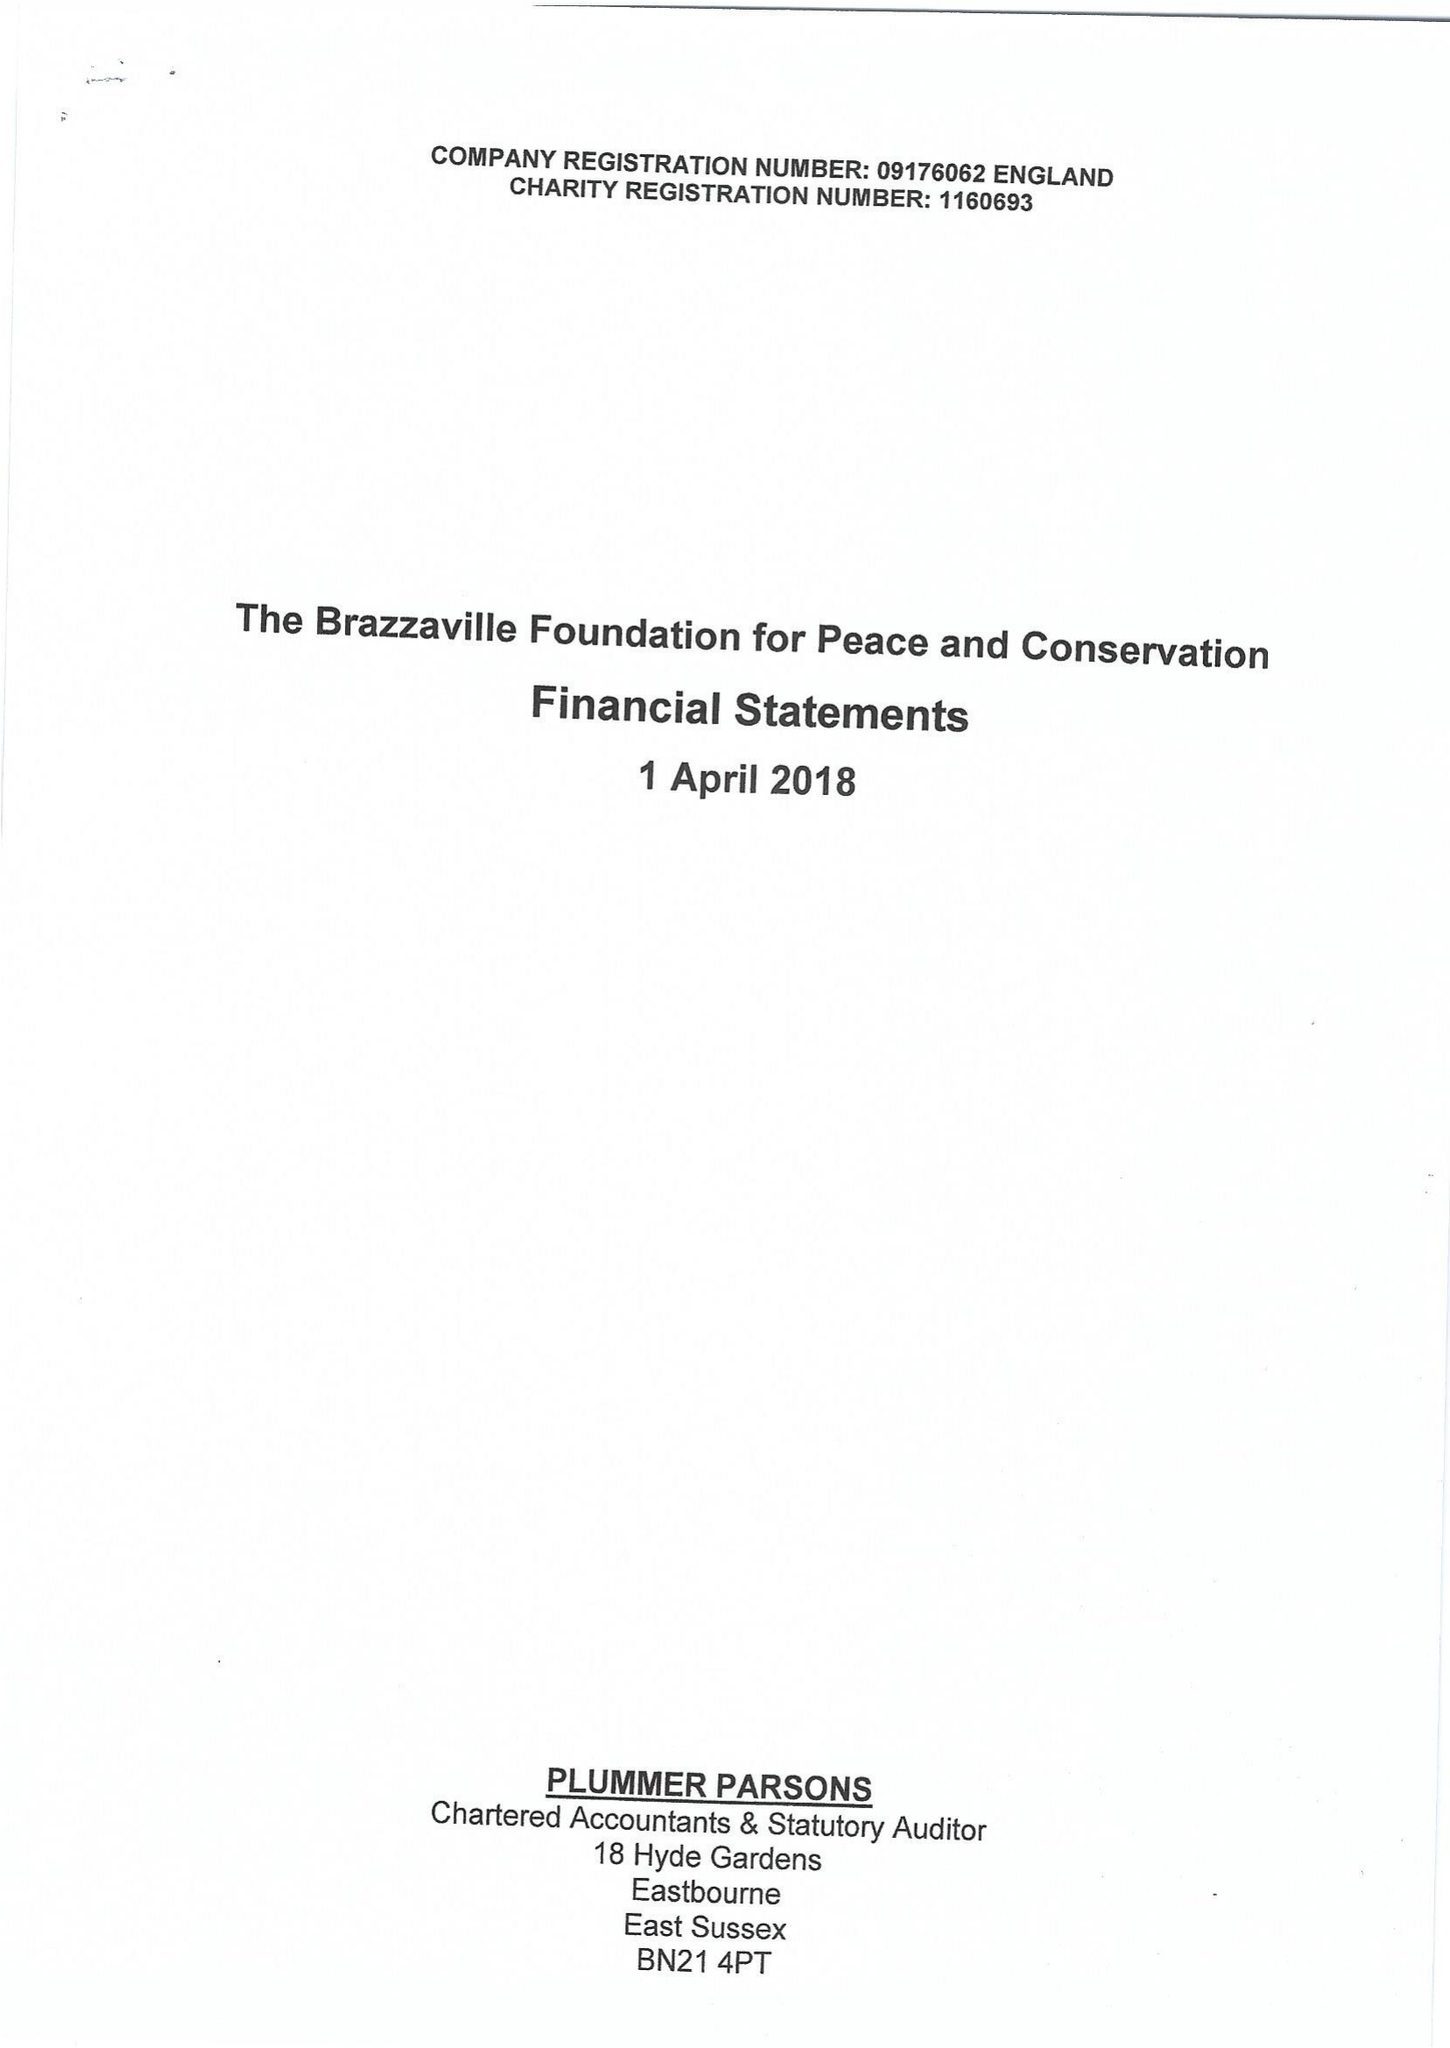What is the value for the address__street_line?
Answer the question using a single word or phrase. 10 QUEEN STREET PLACE 